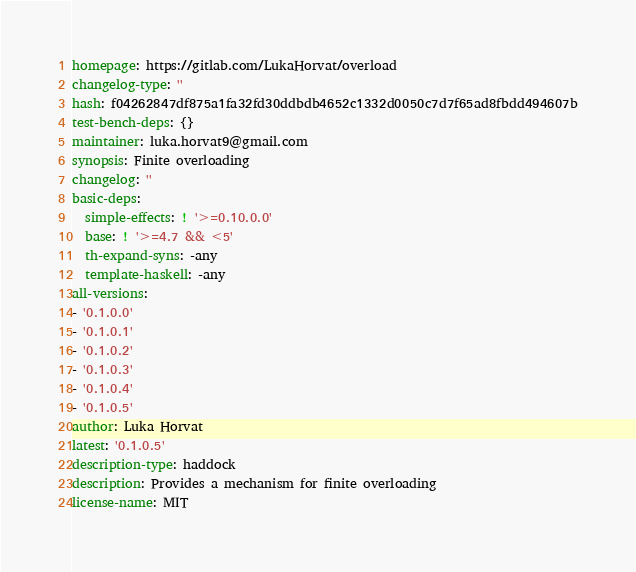Convert code to text. <code><loc_0><loc_0><loc_500><loc_500><_YAML_>homepage: https://gitlab.com/LukaHorvat/overload
changelog-type: ''
hash: f04262847df875a1fa32fd30ddbdb4652c1332d0050c7d7f65ad8fbdd494607b
test-bench-deps: {}
maintainer: luka.horvat9@gmail.com
synopsis: Finite overloading
changelog: ''
basic-deps:
  simple-effects: ! '>=0.10.0.0'
  base: ! '>=4.7 && <5'
  th-expand-syns: -any
  template-haskell: -any
all-versions:
- '0.1.0.0'
- '0.1.0.1'
- '0.1.0.2'
- '0.1.0.3'
- '0.1.0.4'
- '0.1.0.5'
author: Luka Horvat
latest: '0.1.0.5'
description-type: haddock
description: Provides a mechanism for finite overloading
license-name: MIT
</code> 